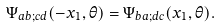Convert formula to latex. <formula><loc_0><loc_0><loc_500><loc_500>\Psi _ { a b ; c d } ( - x _ { 1 } , \theta ) = \Psi _ { b a ; d c } ( x _ { 1 } , \theta ) .</formula> 